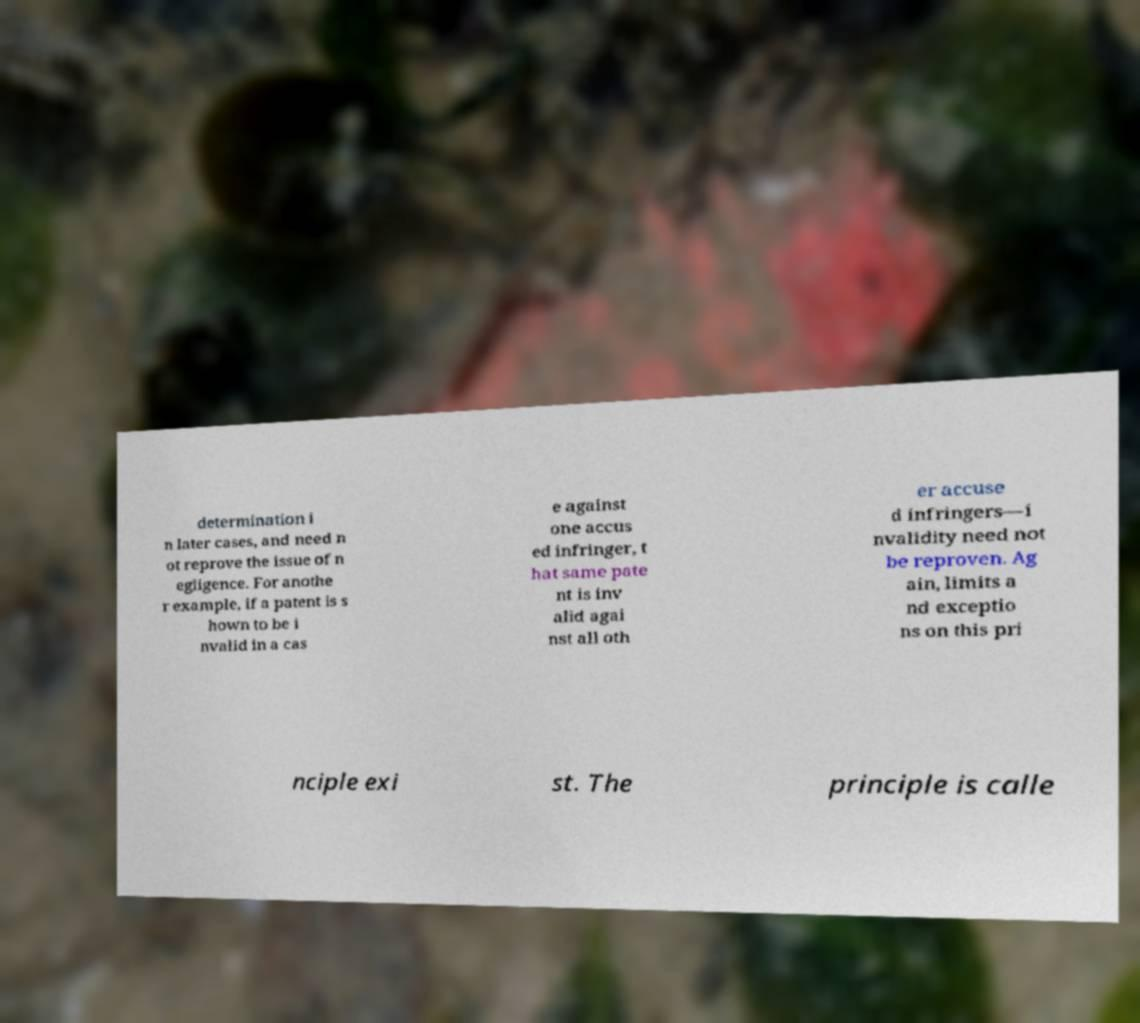Can you accurately transcribe the text from the provided image for me? determination i n later cases, and need n ot reprove the issue of n egligence. For anothe r example, if a patent is s hown to be i nvalid in a cas e against one accus ed infringer, t hat same pate nt is inv alid agai nst all oth er accuse d infringers—i nvalidity need not be reproven. Ag ain, limits a nd exceptio ns on this pri nciple exi st. The principle is calle 